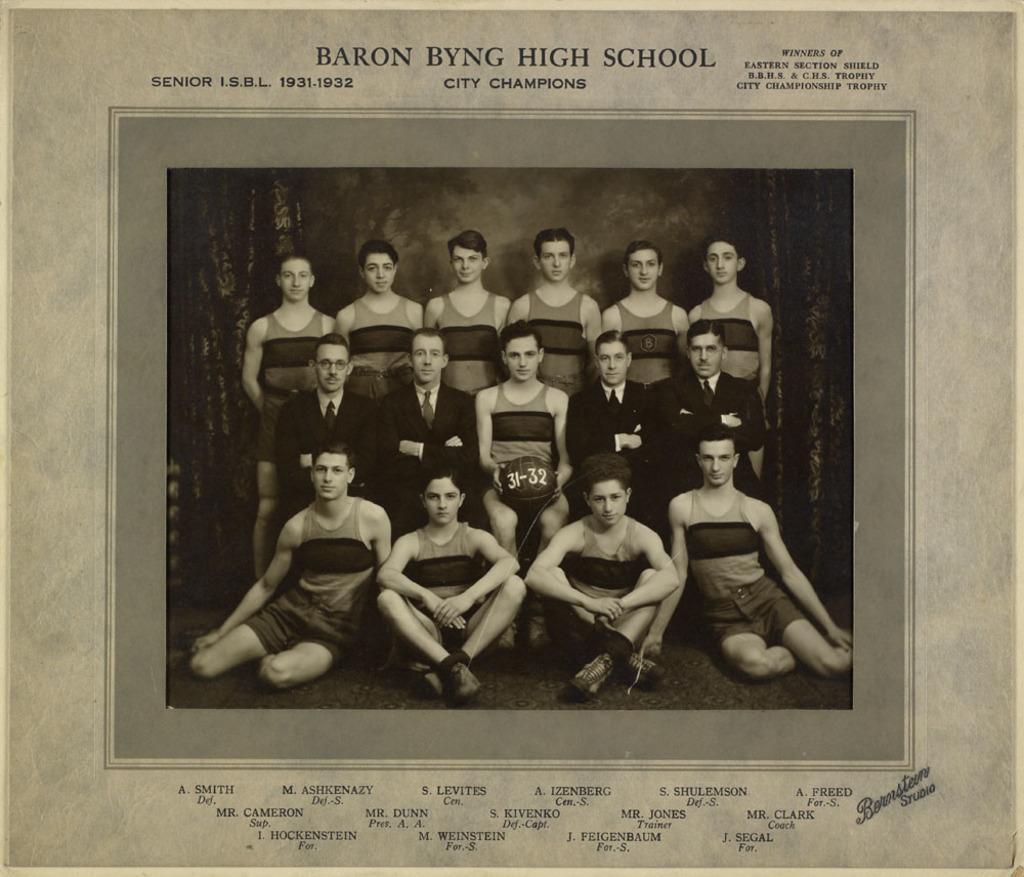Can you describe this image briefly? It is a poster. In this poster, we can see a photograph. In that we can see a group of people. Few are sitting and standing. Here a person is holding a ball. Background we can see a curtains. At the top and bottom of the image, we can see some text. 